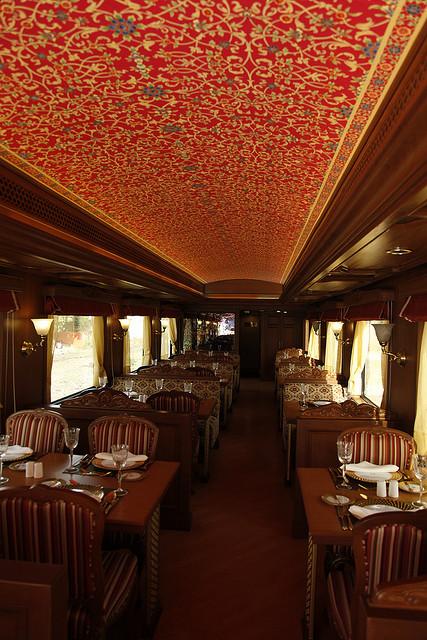Is this a fancy train?
Give a very brief answer. Yes. What style pattern is on the ceiling?
Be succinct. Paisley. Is this a restaurant?
Quick response, please. Yes. 